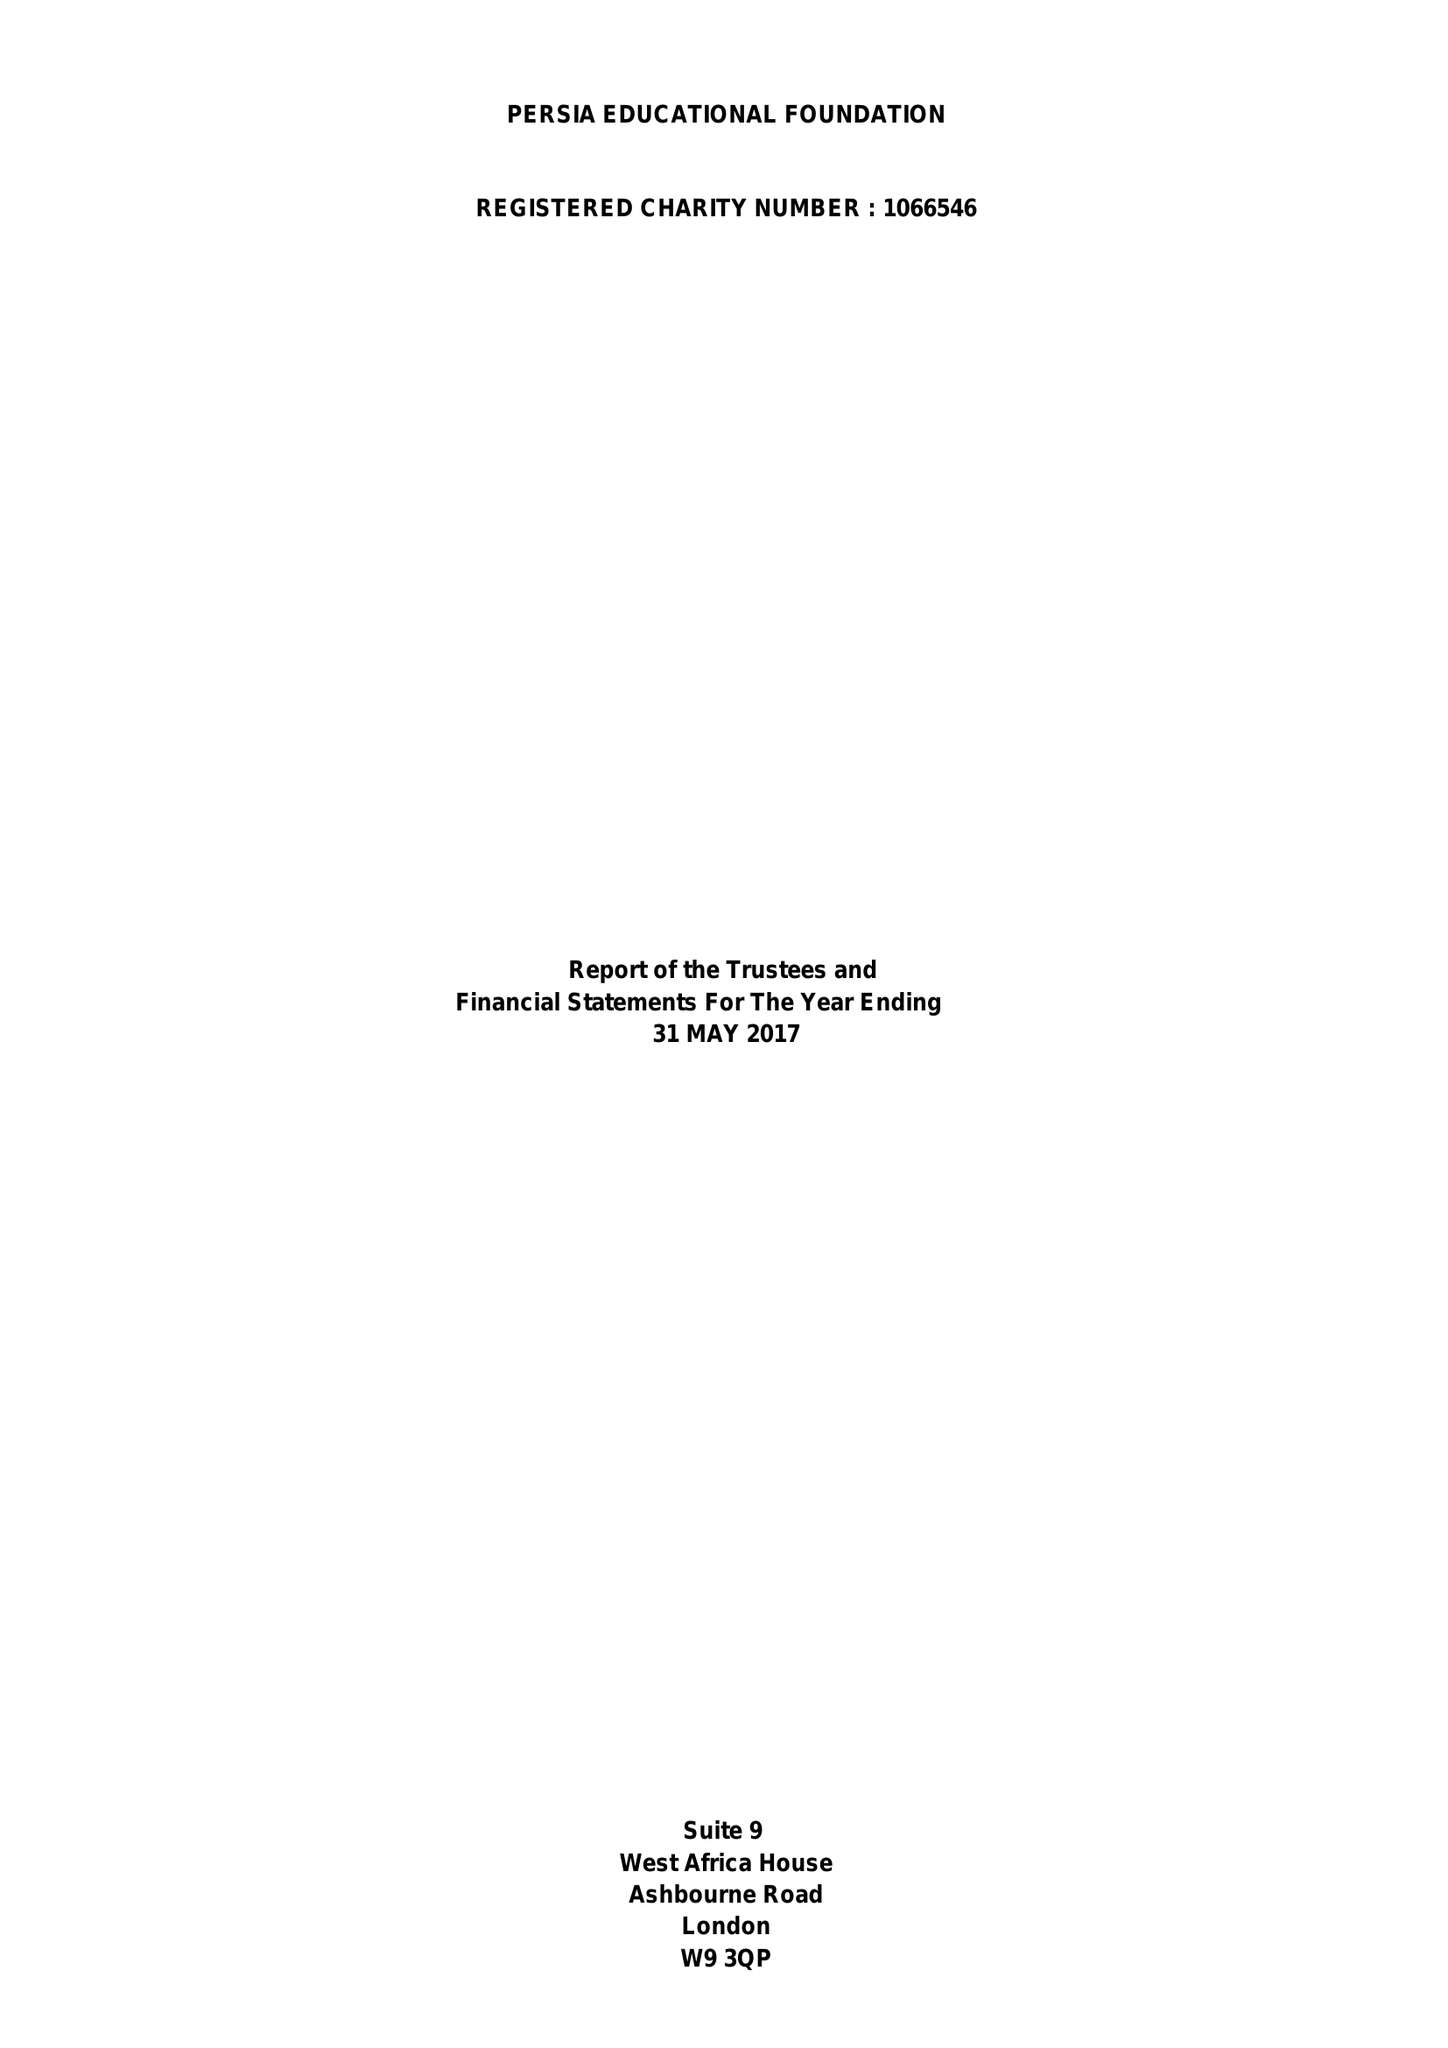What is the value for the charity_name?
Answer the question using a single word or phrase. Persia Educational Foundation 